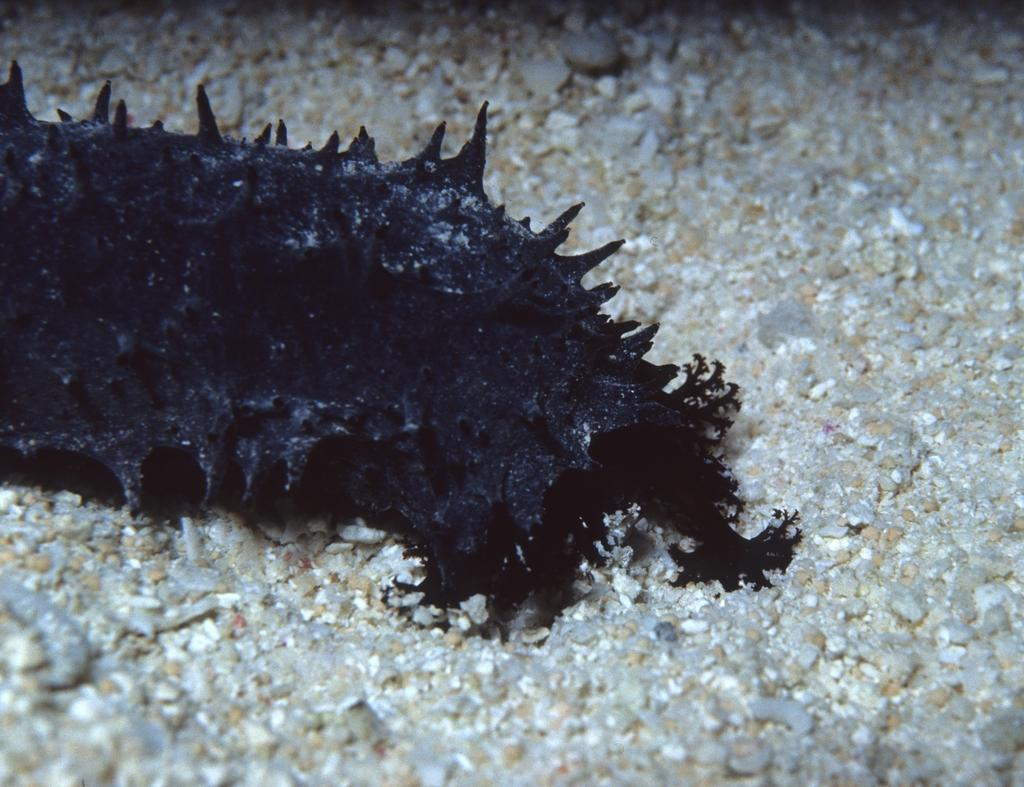What can be seen in the image? There is an object in the image. Can you describe the object's location? The object is on a surface. What type of texture can be seen on the snails in the image? There are no snails present in the image, so it is not possible to determine their texture. 